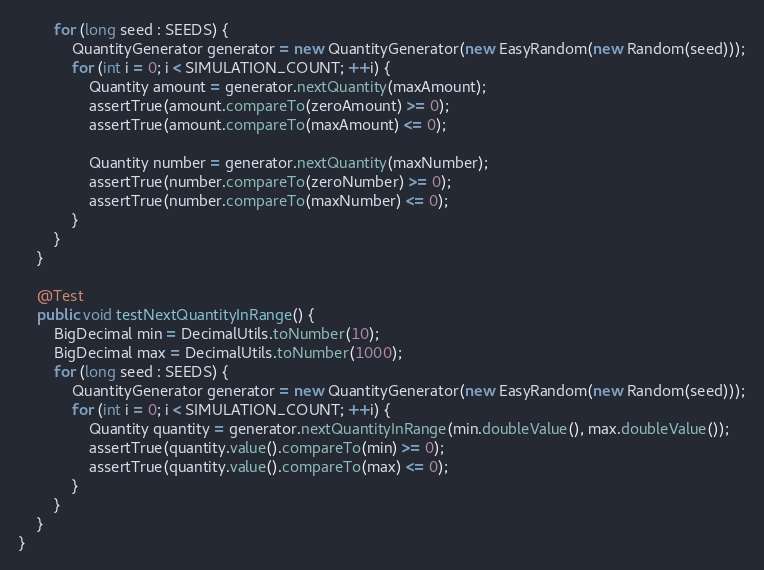<code> <loc_0><loc_0><loc_500><loc_500><_Java_>        for (long seed : SEEDS) {
            QuantityGenerator generator = new QuantityGenerator(new EasyRandom(new Random(seed)));
            for (int i = 0; i < SIMULATION_COUNT; ++i) {
                Quantity amount = generator.nextQuantity(maxAmount);
                assertTrue(amount.compareTo(zeroAmount) >= 0);
                assertTrue(amount.compareTo(maxAmount) <= 0);

                Quantity number = generator.nextQuantity(maxNumber);
                assertTrue(number.compareTo(zeroNumber) >= 0);
                assertTrue(number.compareTo(maxNumber) <= 0);
            }
        }
    }

    @Test
    public void testNextQuantityInRange() {
        BigDecimal min = DecimalUtils.toNumber(10);
        BigDecimal max = DecimalUtils.toNumber(1000);
        for (long seed : SEEDS) {
            QuantityGenerator generator = new QuantityGenerator(new EasyRandom(new Random(seed)));
            for (int i = 0; i < SIMULATION_COUNT; ++i) {
                Quantity quantity = generator.nextQuantityInRange(min.doubleValue(), max.doubleValue());
                assertTrue(quantity.value().compareTo(min) >= 0);
                assertTrue(quantity.value().compareTo(max) <= 0);
            }
        }
    }
}
</code> 